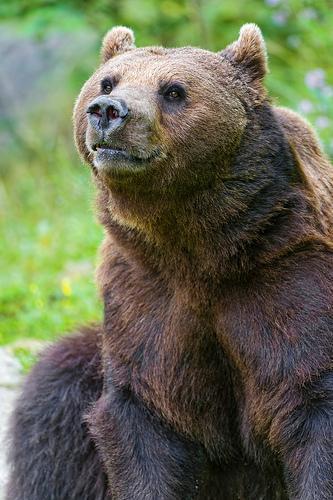How many bears are shown?
Give a very brief answer. 1. How many eyes does bear have?
Give a very brief answer. 2. How many white bears are there?
Give a very brief answer. 0. 